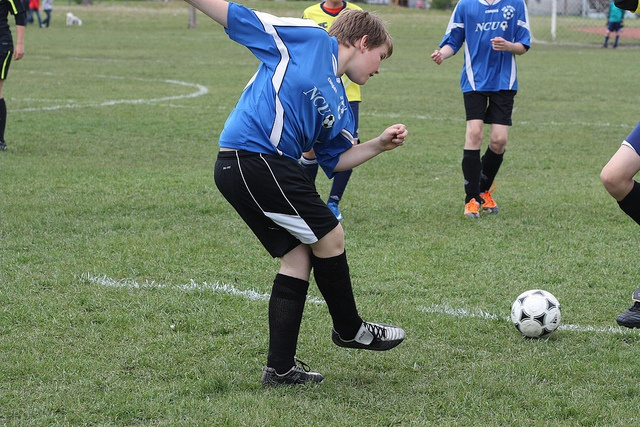Describe the objects in this image and their specific colors. I can see people in green, black, blue, lightblue, and darkgray tones, people in green, black, blue, navy, and gray tones, people in green, black, gray, lightgray, and darkgray tones, people in green, black, khaki, and navy tones, and people in green, black, gray, and olive tones in this image. 